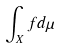Convert formula to latex. <formula><loc_0><loc_0><loc_500><loc_500>\int _ { X } f d \mu</formula> 